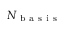Convert formula to latex. <formula><loc_0><loc_0><loc_500><loc_500>{ N _ { b a s i s } }</formula> 